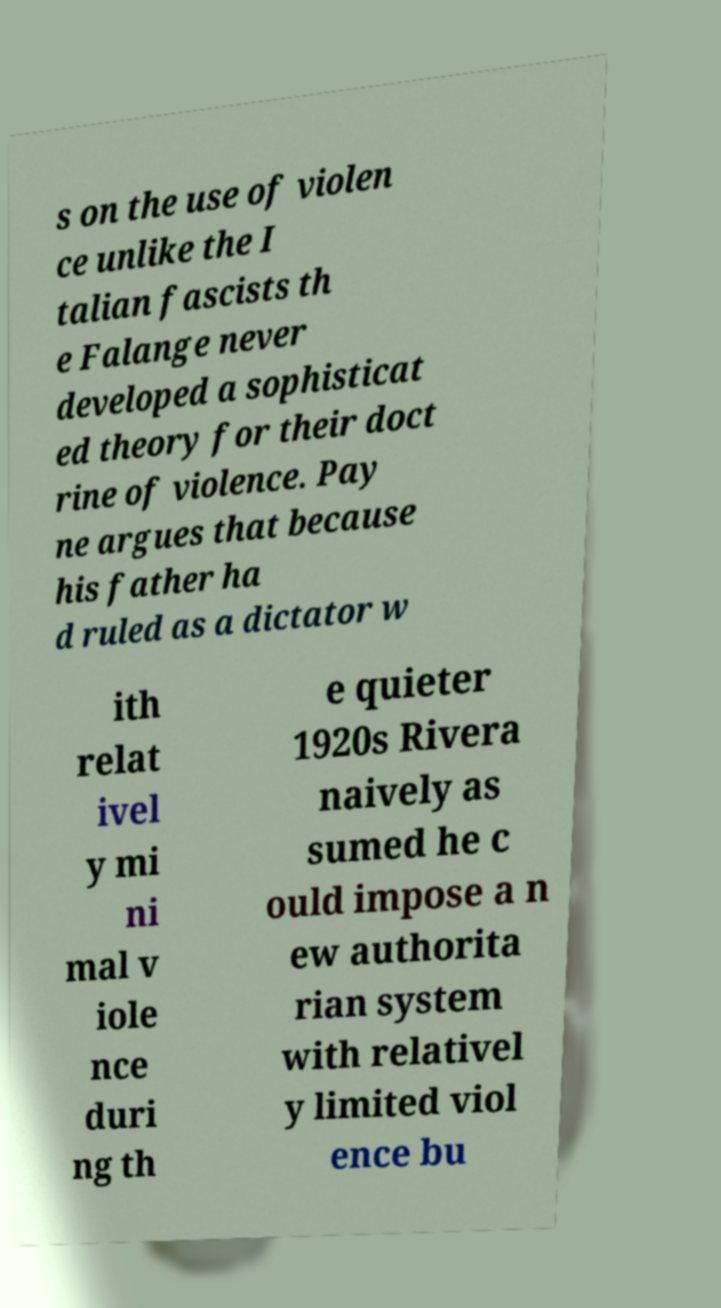There's text embedded in this image that I need extracted. Can you transcribe it verbatim? s on the use of violen ce unlike the I talian fascists th e Falange never developed a sophisticat ed theory for their doct rine of violence. Pay ne argues that because his father ha d ruled as a dictator w ith relat ivel y mi ni mal v iole nce duri ng th e quieter 1920s Rivera naively as sumed he c ould impose a n ew authorita rian system with relativel y limited viol ence bu 